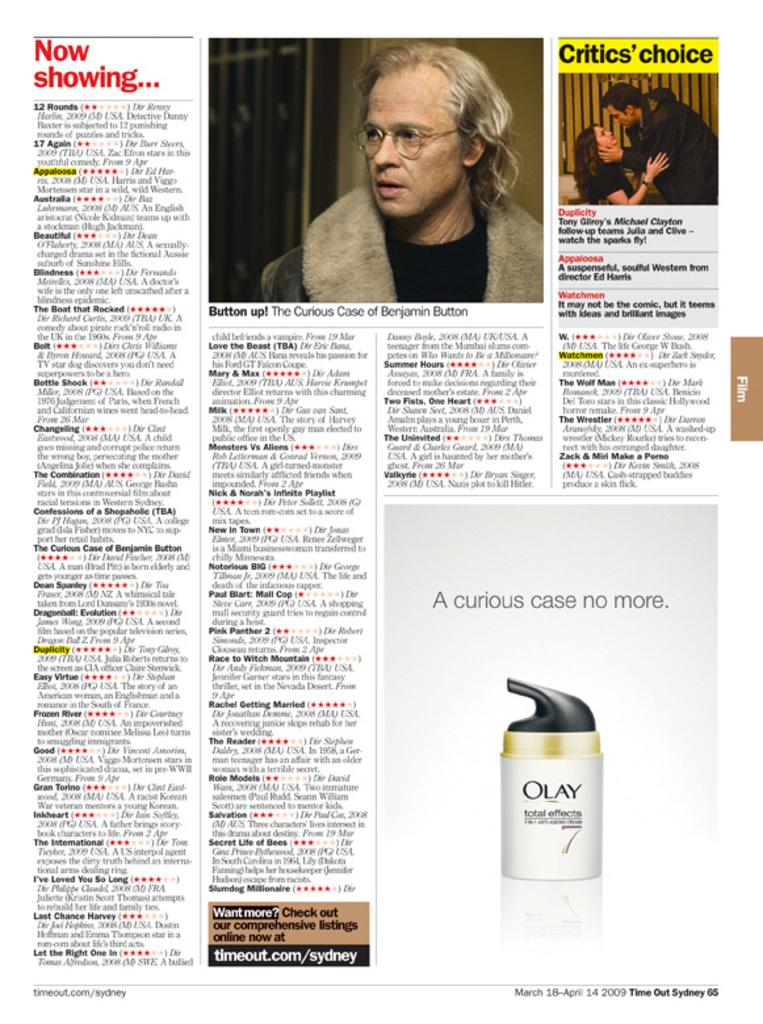What type of publication is visible in the image? There is a magazine in the image. What can be found within the pages of the magazine? The magazine contains images of people and information. Is there any specific product featured in the magazine? Yes, there is an image of a shampoo bottle at the bottom of the magazine. What type of holiday is being celebrated in the image? There is no holiday being celebrated in the image; it features a magazine with images of people, information, and a shampoo bottle. Can you see a card being used in the image? There is no card present in the image; it features a magazine with images of people, information, and a shampoo bottle. 